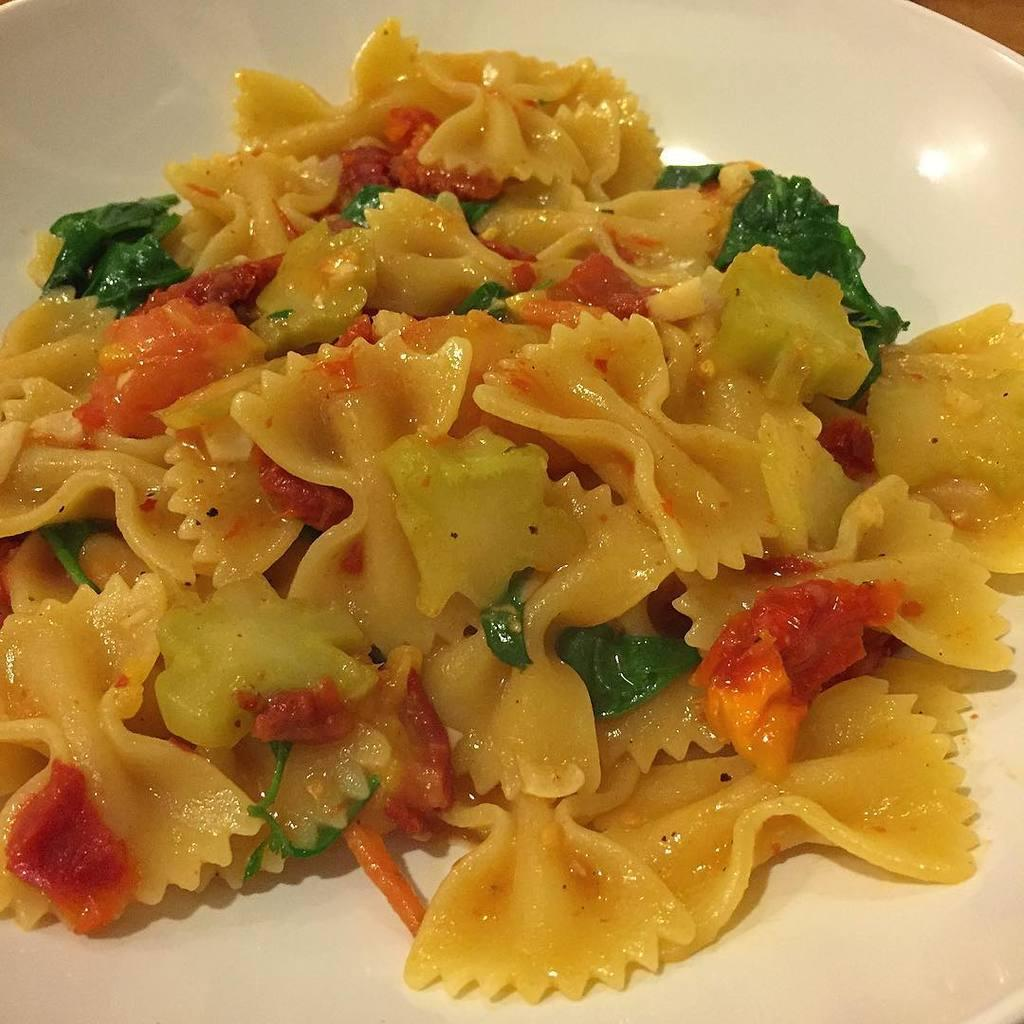What is the main subject of the image? There is a food item in the image. Can you describe the plate on which the food item is placed? The food item is on a white color plate. Is there an umbrella open above the food item in the image? No, there is no umbrella present in the image. Can you tell me how many cables are connected to the food item in the image? There are no cables connected to the food item in the image. 